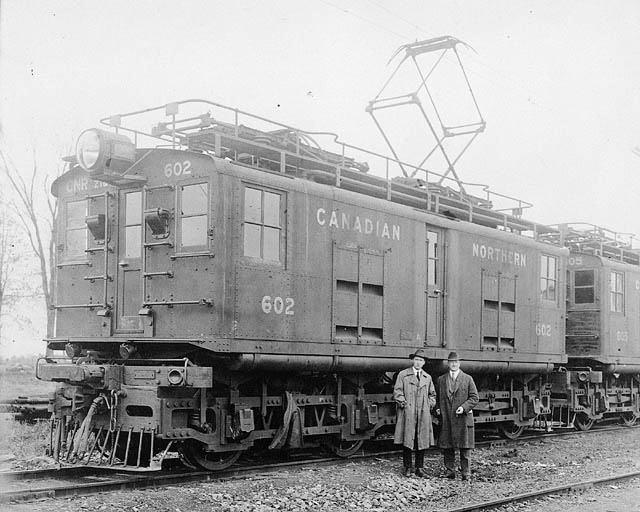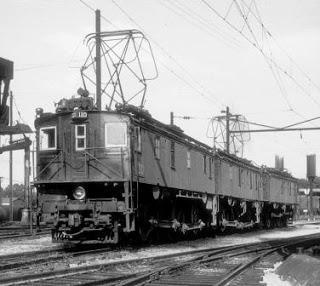The first image is the image on the left, the second image is the image on the right. Given the left and right images, does the statement "There are no humans in the images." hold true? Answer yes or no. No. The first image is the image on the left, the second image is the image on the right. Evaluate the accuracy of this statement regarding the images: "Multiple people are standing in the lefthand vintage train image, and the right image shows a leftward-headed train.". Is it true? Answer yes or no. Yes. 